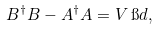Convert formula to latex. <formula><loc_0><loc_0><loc_500><loc_500>B ^ { \dag } B - A ^ { \dag } A = V \, \i d ,</formula> 